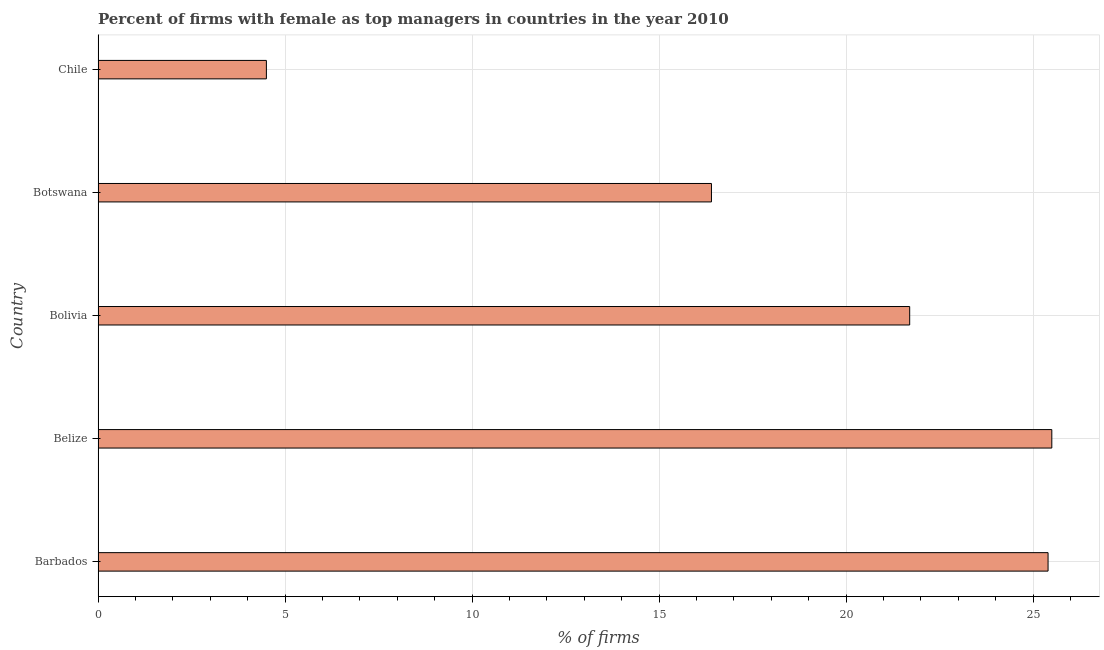Does the graph contain any zero values?
Ensure brevity in your answer.  No. Does the graph contain grids?
Keep it short and to the point. Yes. What is the title of the graph?
Your response must be concise. Percent of firms with female as top managers in countries in the year 2010. What is the label or title of the X-axis?
Ensure brevity in your answer.  % of firms. What is the percentage of firms with female as top manager in Botswana?
Your answer should be compact. 16.4. Across all countries, what is the maximum percentage of firms with female as top manager?
Provide a short and direct response. 25.5. Across all countries, what is the minimum percentage of firms with female as top manager?
Your response must be concise. 4.5. In which country was the percentage of firms with female as top manager maximum?
Make the answer very short. Belize. In which country was the percentage of firms with female as top manager minimum?
Provide a succinct answer. Chile. What is the sum of the percentage of firms with female as top manager?
Provide a succinct answer. 93.5. What is the difference between the percentage of firms with female as top manager in Belize and Chile?
Ensure brevity in your answer.  21. What is the average percentage of firms with female as top manager per country?
Provide a short and direct response. 18.7. What is the median percentage of firms with female as top manager?
Ensure brevity in your answer.  21.7. In how many countries, is the percentage of firms with female as top manager greater than 10 %?
Offer a terse response. 4. What is the ratio of the percentage of firms with female as top manager in Belize to that in Chile?
Ensure brevity in your answer.  5.67. In how many countries, is the percentage of firms with female as top manager greater than the average percentage of firms with female as top manager taken over all countries?
Your answer should be very brief. 3. How many countries are there in the graph?
Your response must be concise. 5. What is the difference between two consecutive major ticks on the X-axis?
Provide a succinct answer. 5. Are the values on the major ticks of X-axis written in scientific E-notation?
Ensure brevity in your answer.  No. What is the % of firms of Barbados?
Your response must be concise. 25.4. What is the % of firms in Belize?
Keep it short and to the point. 25.5. What is the % of firms in Bolivia?
Your response must be concise. 21.7. What is the difference between the % of firms in Barbados and Belize?
Offer a terse response. -0.1. What is the difference between the % of firms in Barbados and Botswana?
Ensure brevity in your answer.  9. What is the difference between the % of firms in Barbados and Chile?
Give a very brief answer. 20.9. What is the difference between the % of firms in Belize and Bolivia?
Ensure brevity in your answer.  3.8. What is the difference between the % of firms in Belize and Botswana?
Provide a short and direct response. 9.1. What is the difference between the % of firms in Bolivia and Botswana?
Your response must be concise. 5.3. What is the difference between the % of firms in Bolivia and Chile?
Provide a succinct answer. 17.2. What is the ratio of the % of firms in Barbados to that in Belize?
Offer a terse response. 1. What is the ratio of the % of firms in Barbados to that in Bolivia?
Provide a short and direct response. 1.17. What is the ratio of the % of firms in Barbados to that in Botswana?
Offer a terse response. 1.55. What is the ratio of the % of firms in Barbados to that in Chile?
Give a very brief answer. 5.64. What is the ratio of the % of firms in Belize to that in Bolivia?
Your answer should be compact. 1.18. What is the ratio of the % of firms in Belize to that in Botswana?
Give a very brief answer. 1.55. What is the ratio of the % of firms in Belize to that in Chile?
Your answer should be compact. 5.67. What is the ratio of the % of firms in Bolivia to that in Botswana?
Make the answer very short. 1.32. What is the ratio of the % of firms in Bolivia to that in Chile?
Make the answer very short. 4.82. What is the ratio of the % of firms in Botswana to that in Chile?
Your response must be concise. 3.64. 